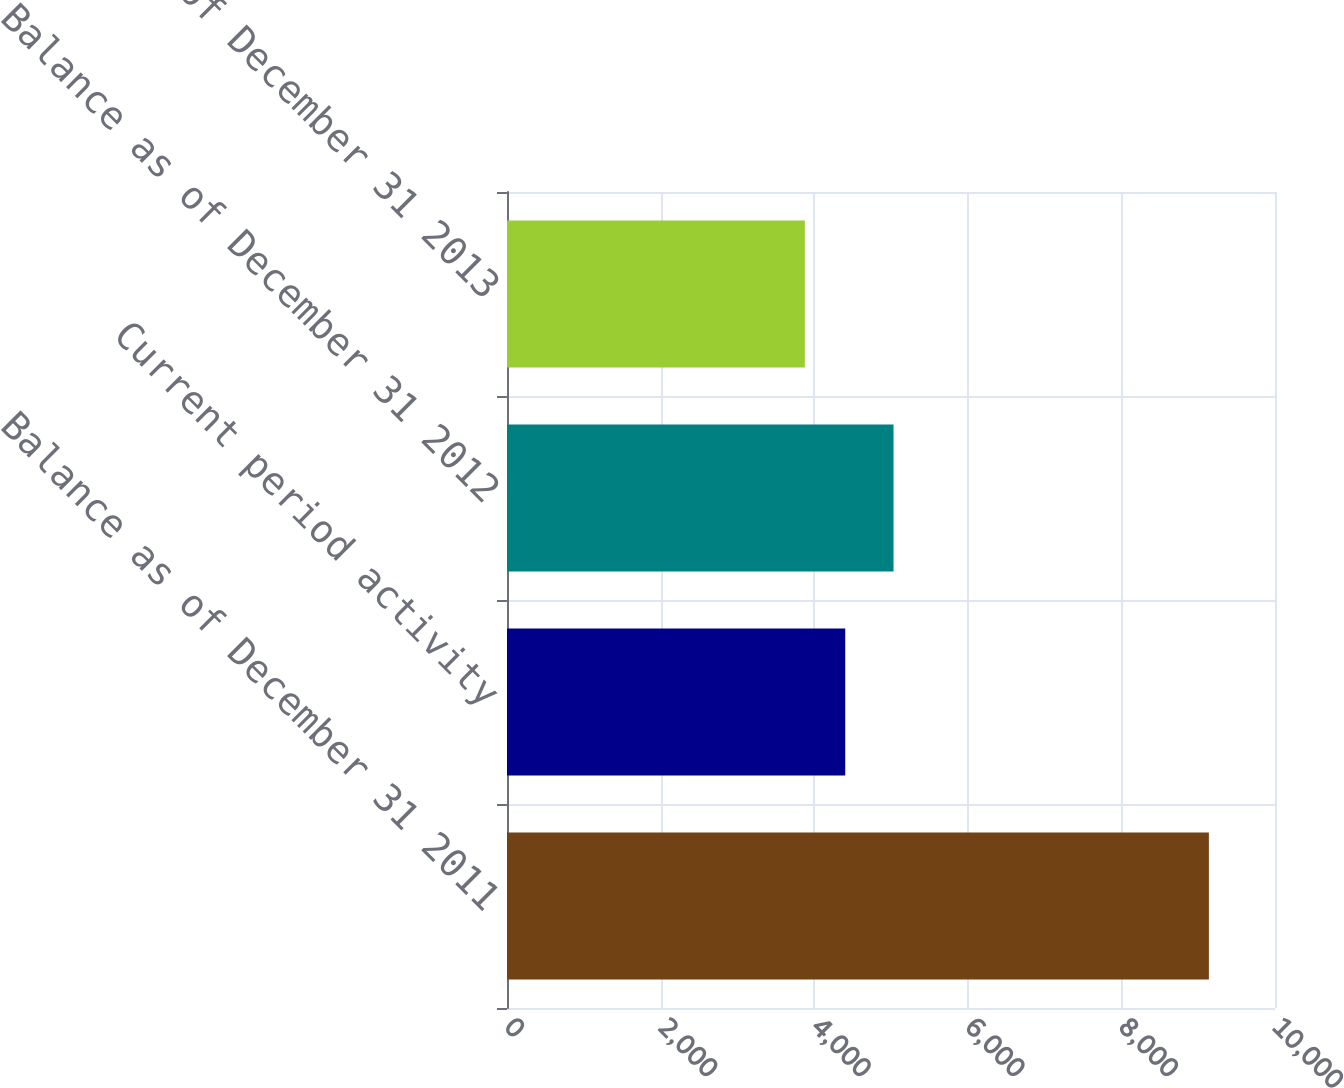Convert chart. <chart><loc_0><loc_0><loc_500><loc_500><bar_chart><fcel>Balance as of December 31 2011<fcel>Current period activity<fcel>Balance as of December 31 2012<fcel>Balance as of December 31 2013<nl><fcel>9139<fcel>4404.1<fcel>5033<fcel>3878<nl></chart> 